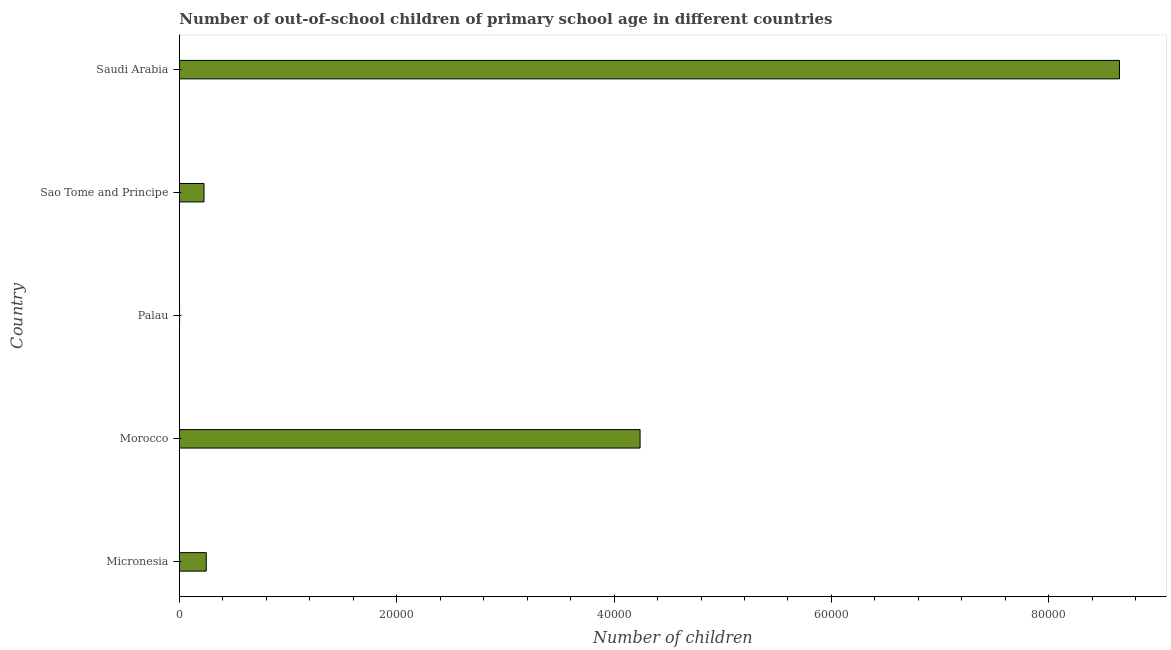Does the graph contain any zero values?
Provide a succinct answer. No. What is the title of the graph?
Ensure brevity in your answer.  Number of out-of-school children of primary school age in different countries. What is the label or title of the X-axis?
Give a very brief answer. Number of children. What is the number of out-of-school children in Micronesia?
Ensure brevity in your answer.  2470. Across all countries, what is the maximum number of out-of-school children?
Offer a very short reply. 8.65e+04. In which country was the number of out-of-school children maximum?
Make the answer very short. Saudi Arabia. In which country was the number of out-of-school children minimum?
Your answer should be very brief. Palau. What is the sum of the number of out-of-school children?
Ensure brevity in your answer.  1.34e+05. What is the difference between the number of out-of-school children in Micronesia and Sao Tome and Principe?
Offer a terse response. 208. What is the average number of out-of-school children per country?
Give a very brief answer. 2.67e+04. What is the median number of out-of-school children?
Offer a very short reply. 2470. In how many countries, is the number of out-of-school children greater than 4000 ?
Provide a succinct answer. 2. Is the difference between the number of out-of-school children in Micronesia and Morocco greater than the difference between any two countries?
Offer a terse response. No. What is the difference between the highest and the second highest number of out-of-school children?
Provide a short and direct response. 4.41e+04. Is the sum of the number of out-of-school children in Micronesia and Saudi Arabia greater than the maximum number of out-of-school children across all countries?
Provide a succinct answer. Yes. What is the difference between the highest and the lowest number of out-of-school children?
Provide a succinct answer. 8.65e+04. In how many countries, is the number of out-of-school children greater than the average number of out-of-school children taken over all countries?
Your answer should be very brief. 2. Are all the bars in the graph horizontal?
Keep it short and to the point. Yes. What is the Number of children of Micronesia?
Offer a terse response. 2470. What is the Number of children of Morocco?
Ensure brevity in your answer.  4.24e+04. What is the Number of children in Palau?
Give a very brief answer. 13. What is the Number of children in Sao Tome and Principe?
Your answer should be very brief. 2262. What is the Number of children of Saudi Arabia?
Give a very brief answer. 8.65e+04. What is the difference between the Number of children in Micronesia and Morocco?
Make the answer very short. -3.99e+04. What is the difference between the Number of children in Micronesia and Palau?
Give a very brief answer. 2457. What is the difference between the Number of children in Micronesia and Sao Tome and Principe?
Provide a succinct answer. 208. What is the difference between the Number of children in Micronesia and Saudi Arabia?
Your response must be concise. -8.40e+04. What is the difference between the Number of children in Morocco and Palau?
Provide a short and direct response. 4.24e+04. What is the difference between the Number of children in Morocco and Sao Tome and Principe?
Your answer should be compact. 4.01e+04. What is the difference between the Number of children in Morocco and Saudi Arabia?
Offer a terse response. -4.41e+04. What is the difference between the Number of children in Palau and Sao Tome and Principe?
Offer a terse response. -2249. What is the difference between the Number of children in Palau and Saudi Arabia?
Your response must be concise. -8.65e+04. What is the difference between the Number of children in Sao Tome and Principe and Saudi Arabia?
Keep it short and to the point. -8.43e+04. What is the ratio of the Number of children in Micronesia to that in Morocco?
Make the answer very short. 0.06. What is the ratio of the Number of children in Micronesia to that in Palau?
Offer a very short reply. 190. What is the ratio of the Number of children in Micronesia to that in Sao Tome and Principe?
Ensure brevity in your answer.  1.09. What is the ratio of the Number of children in Micronesia to that in Saudi Arabia?
Offer a terse response. 0.03. What is the ratio of the Number of children in Morocco to that in Palau?
Your answer should be very brief. 3261.08. What is the ratio of the Number of children in Morocco to that in Sao Tome and Principe?
Make the answer very short. 18.74. What is the ratio of the Number of children in Morocco to that in Saudi Arabia?
Offer a very short reply. 0.49. What is the ratio of the Number of children in Palau to that in Sao Tome and Principe?
Give a very brief answer. 0.01. What is the ratio of the Number of children in Palau to that in Saudi Arabia?
Offer a very short reply. 0. What is the ratio of the Number of children in Sao Tome and Principe to that in Saudi Arabia?
Make the answer very short. 0.03. 